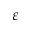<formula> <loc_0><loc_0><loc_500><loc_500>\varepsilon</formula> 